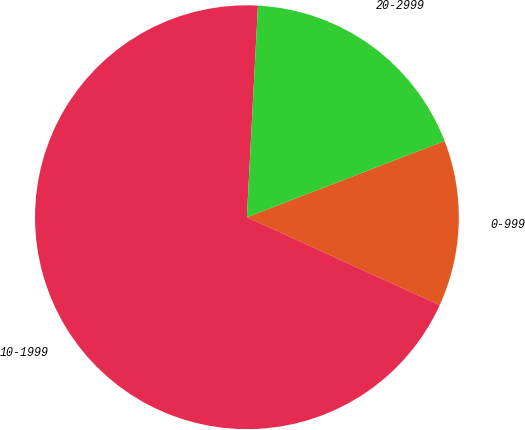Convert chart to OTSL. <chart><loc_0><loc_0><loc_500><loc_500><pie_chart><fcel>0-999<fcel>10-1999<fcel>20-2999<nl><fcel>12.67%<fcel>69.02%<fcel>18.31%<nl></chart> 